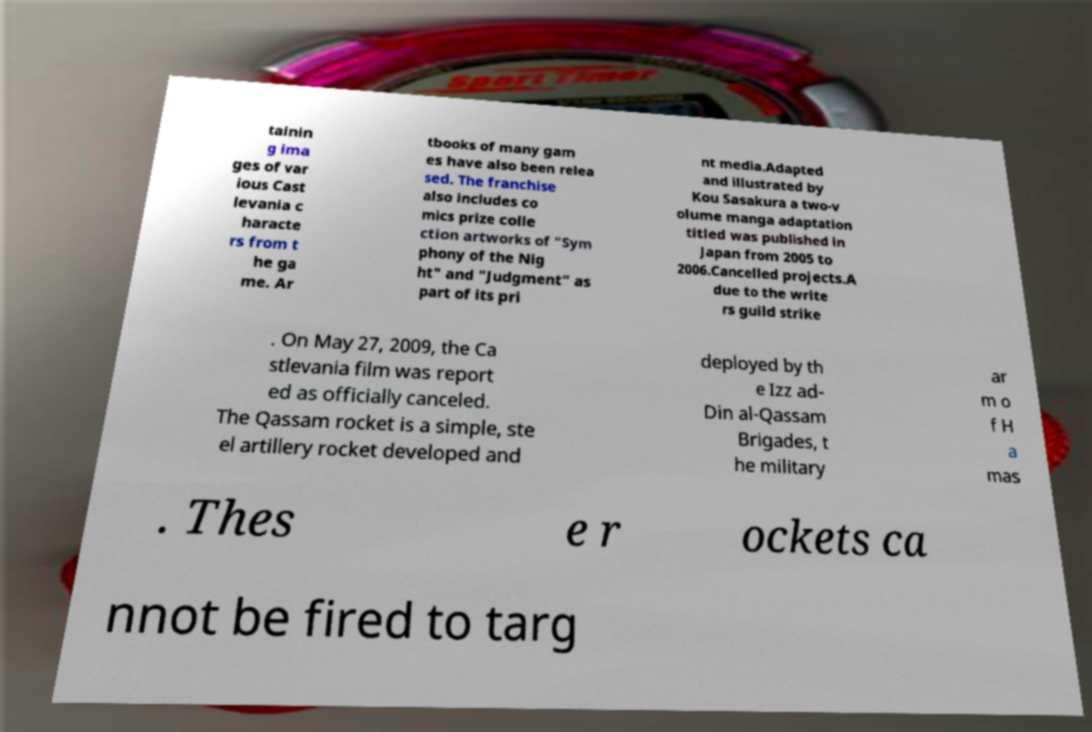There's text embedded in this image that I need extracted. Can you transcribe it verbatim? tainin g ima ges of var ious Cast levania c haracte rs from t he ga me. Ar tbooks of many gam es have also been relea sed. The franchise also includes co mics prize colle ction artworks of "Sym phony of the Nig ht" and "Judgment" as part of its pri nt media.Adapted and illustrated by Kou Sasakura a two-v olume manga adaptation titled was published in Japan from 2005 to 2006.Cancelled projects.A due to the write rs guild strike . On May 27, 2009, the Ca stlevania film was report ed as officially canceled. The Qassam rocket is a simple, ste el artillery rocket developed and deployed by th e Izz ad- Din al-Qassam Brigades, t he military ar m o f H a mas . Thes e r ockets ca nnot be fired to targ 